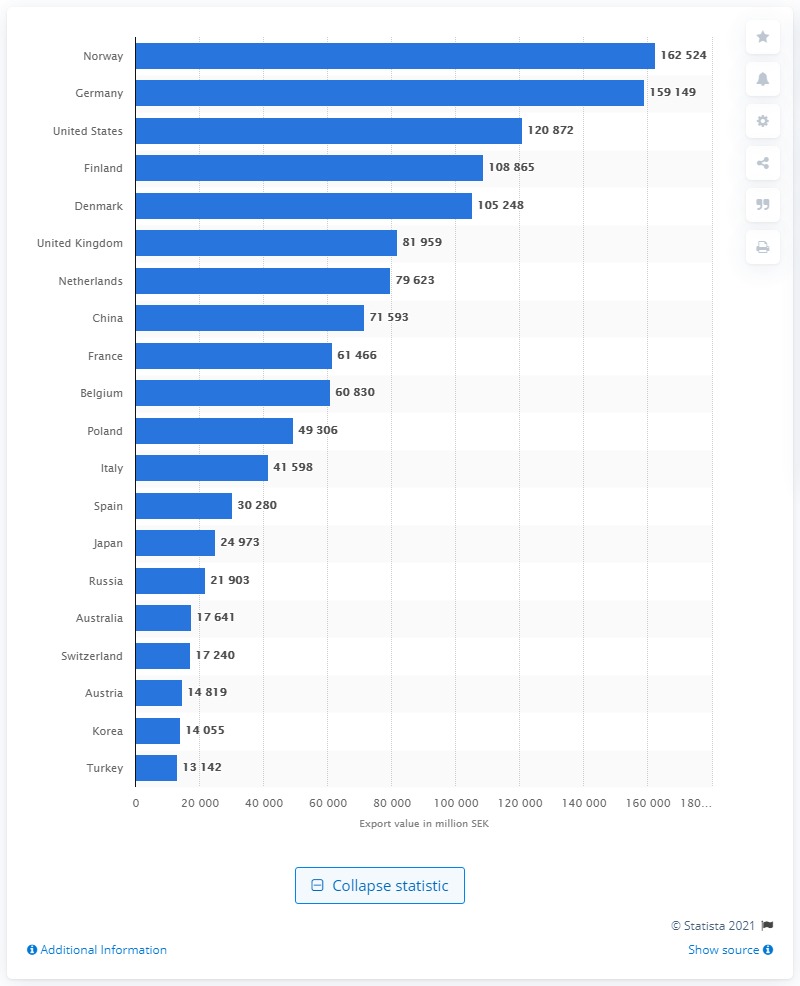Give some essential details in this illustration. In 2019, Germany was Sweden's second largest export destination, accounting for a significant portion of Sweden's total international trade. In 2019, Sweden's biggest trading partner was Norway. In 2019, Norway's total export value in Swedish kronor was 162,524. 